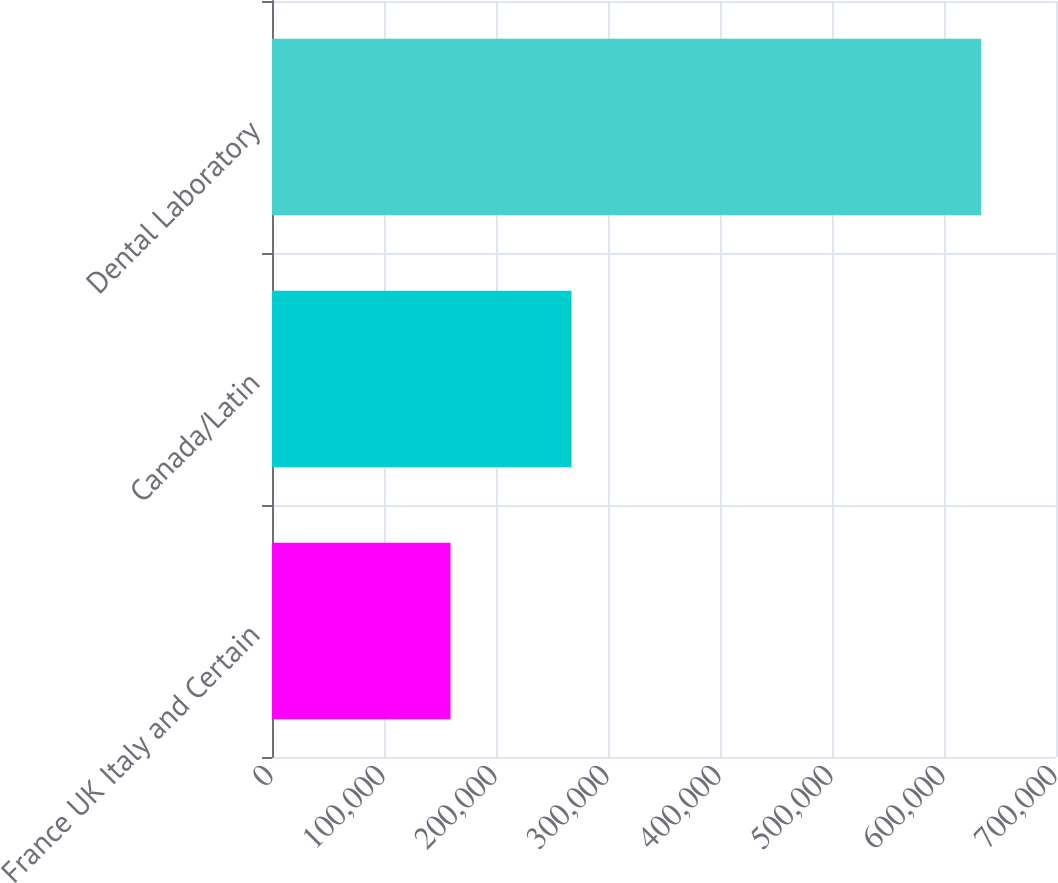Convert chart to OTSL. <chart><loc_0><loc_0><loc_500><loc_500><bar_chart><fcel>France UK Italy and Certain<fcel>Canada/Latin<fcel>Dental Laboratory<nl><fcel>159383<fcel>267427<fcel>633248<nl></chart> 